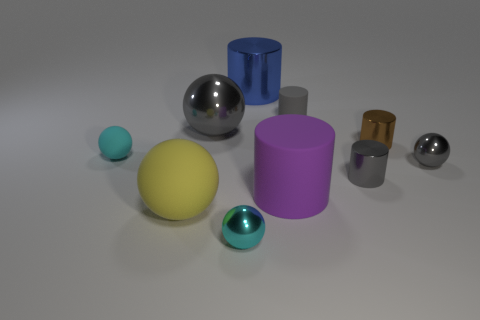What number of small things are the same color as the small matte cylinder?
Your response must be concise. 2. What is the shape of the small cyan thing behind the small cyan thing that is to the right of the big gray shiny ball?
Offer a very short reply. Sphere. What number of brown objects have the same material as the big purple thing?
Your answer should be compact. 0. What is the material of the tiny gray object that is on the left side of the gray shiny cylinder?
Keep it short and to the point. Rubber. What shape is the tiny matte object to the right of the big cylinder in front of the gray metal sphere that is to the right of the big metal cylinder?
Provide a short and direct response. Cylinder. Is the color of the small shiny cylinder on the left side of the tiny brown metallic thing the same as the tiny shiny ball to the right of the small gray rubber thing?
Your response must be concise. Yes. Are there fewer cyan rubber balls on the right side of the purple rubber cylinder than small cylinders to the right of the small gray matte object?
Your answer should be very brief. Yes. The other large metallic object that is the same shape as the big yellow object is what color?
Keep it short and to the point. Gray. There is a large purple thing; is its shape the same as the tiny cyan metal object that is in front of the large purple matte cylinder?
Make the answer very short. No. What number of things are either rubber cylinders that are on the right side of the large purple cylinder or cylinders that are on the right side of the purple rubber cylinder?
Your answer should be very brief. 3. 